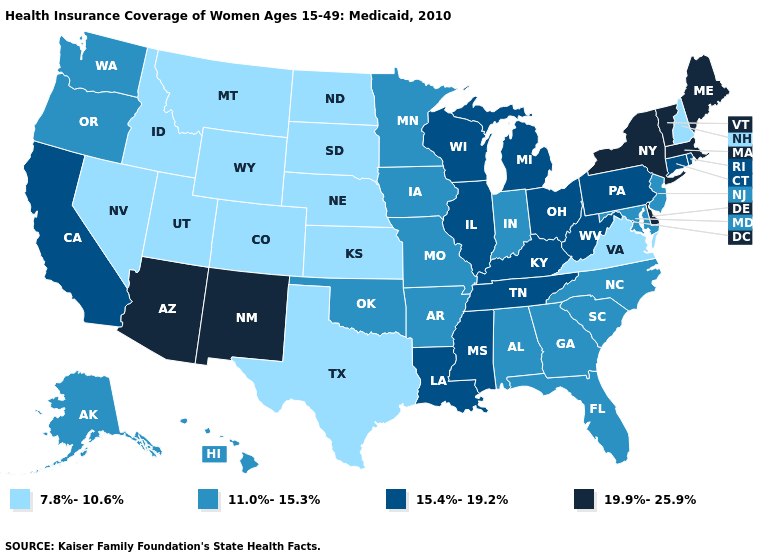Does the map have missing data?
Write a very short answer. No. Does New Hampshire have the lowest value in the Northeast?
Quick response, please. Yes. How many symbols are there in the legend?
Answer briefly. 4. Among the states that border California , does Nevada have the lowest value?
Answer briefly. Yes. Is the legend a continuous bar?
Give a very brief answer. No. Does Wyoming have the highest value in the West?
Answer briefly. No. What is the value of Idaho?
Answer briefly. 7.8%-10.6%. What is the value of Rhode Island?
Short answer required. 15.4%-19.2%. Is the legend a continuous bar?
Short answer required. No. What is the highest value in the Northeast ?
Quick response, please. 19.9%-25.9%. Does the map have missing data?
Be succinct. No. Name the states that have a value in the range 11.0%-15.3%?
Concise answer only. Alabama, Alaska, Arkansas, Florida, Georgia, Hawaii, Indiana, Iowa, Maryland, Minnesota, Missouri, New Jersey, North Carolina, Oklahoma, Oregon, South Carolina, Washington. Which states have the lowest value in the USA?
Quick response, please. Colorado, Idaho, Kansas, Montana, Nebraska, Nevada, New Hampshire, North Dakota, South Dakota, Texas, Utah, Virginia, Wyoming. Does Maryland have the highest value in the South?
Give a very brief answer. No. What is the value of Utah?
Answer briefly. 7.8%-10.6%. 